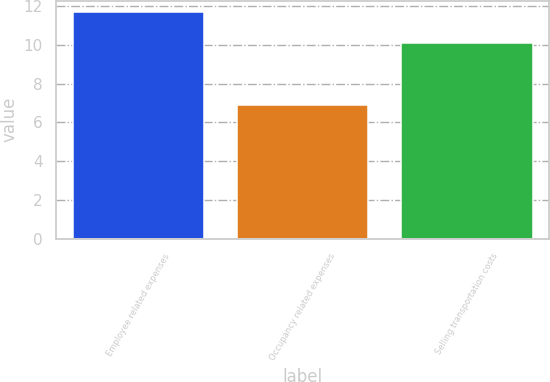<chart> <loc_0><loc_0><loc_500><loc_500><bar_chart><fcel>Employee related expenses<fcel>Occupancy related expenses<fcel>Selling transportation costs<nl><fcel>11.7<fcel>6.9<fcel>10.1<nl></chart> 